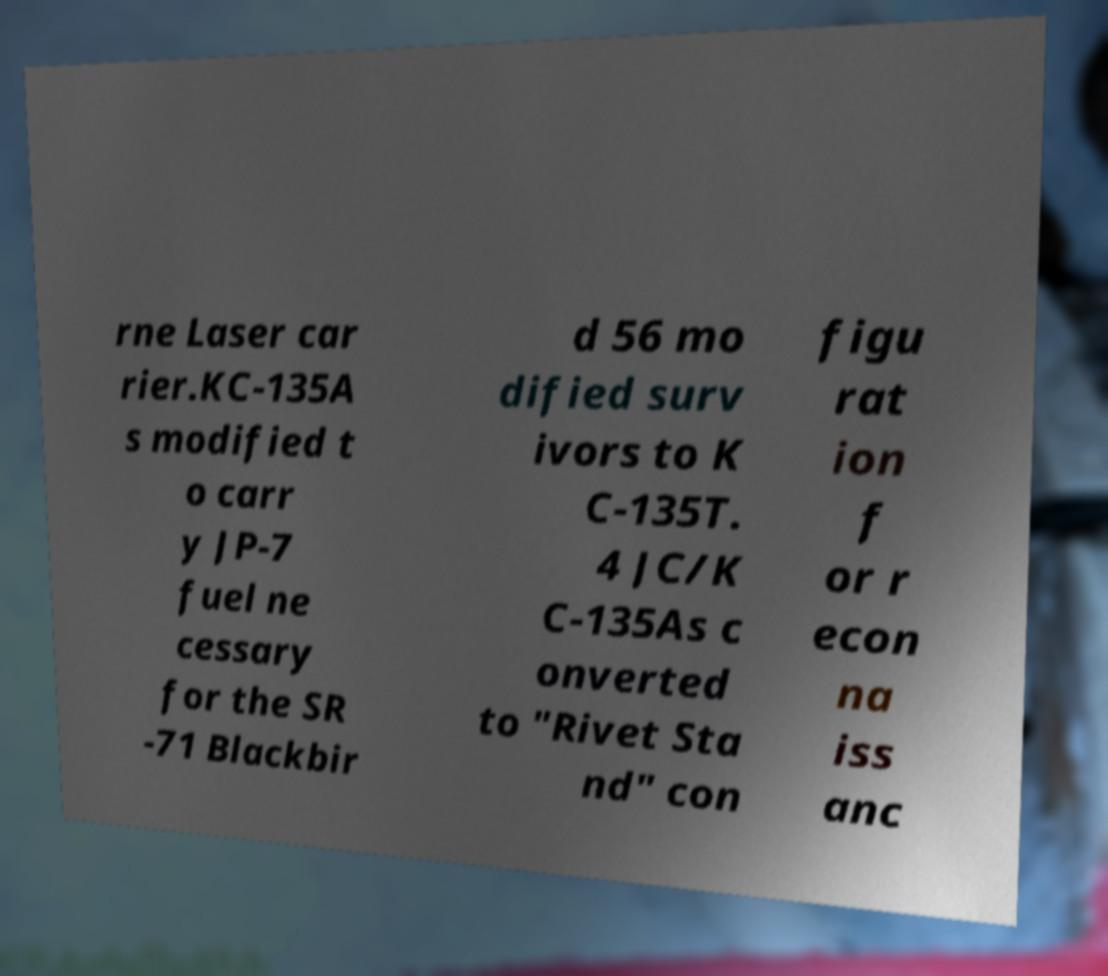Can you accurately transcribe the text from the provided image for me? rne Laser car rier.KC-135A s modified t o carr y JP-7 fuel ne cessary for the SR -71 Blackbir d 56 mo dified surv ivors to K C-135T. 4 JC/K C-135As c onverted to "Rivet Sta nd" con figu rat ion f or r econ na iss anc 